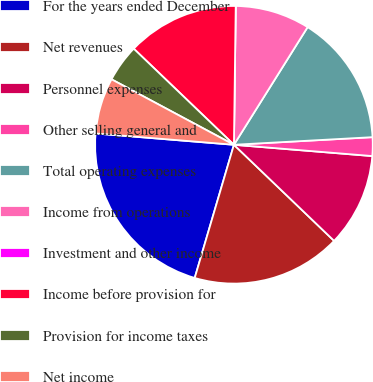Convert chart. <chart><loc_0><loc_0><loc_500><loc_500><pie_chart><fcel>For the years ended December<fcel>Net revenues<fcel>Personnel expenses<fcel>Other selling general and<fcel>Total operating expenses<fcel>Income from operations<fcel>Investment and other income<fcel>Income before provision for<fcel>Provision for income taxes<fcel>Net income<nl><fcel>21.74%<fcel>17.39%<fcel>10.87%<fcel>2.17%<fcel>15.22%<fcel>8.7%<fcel>0.0%<fcel>13.04%<fcel>4.35%<fcel>6.52%<nl></chart> 